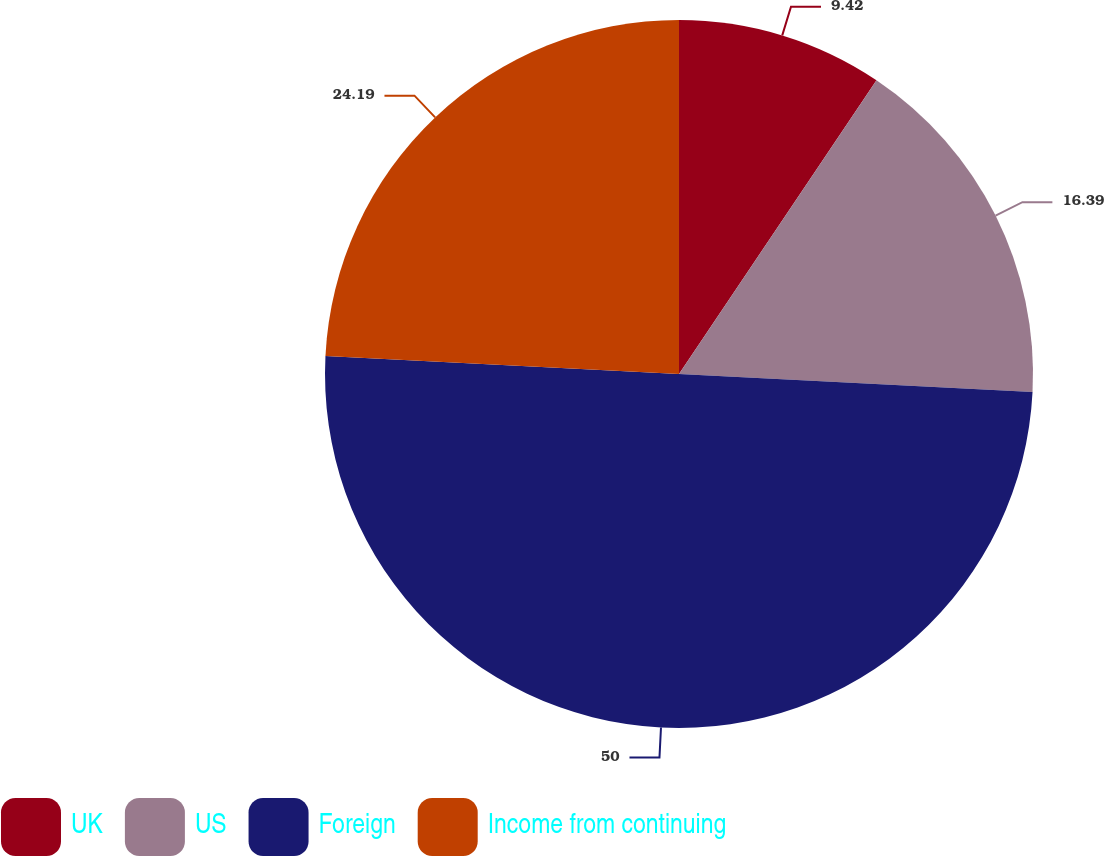Convert chart. <chart><loc_0><loc_0><loc_500><loc_500><pie_chart><fcel>UK<fcel>US<fcel>Foreign<fcel>Income from continuing<nl><fcel>9.42%<fcel>16.39%<fcel>50.0%<fcel>24.19%<nl></chart> 